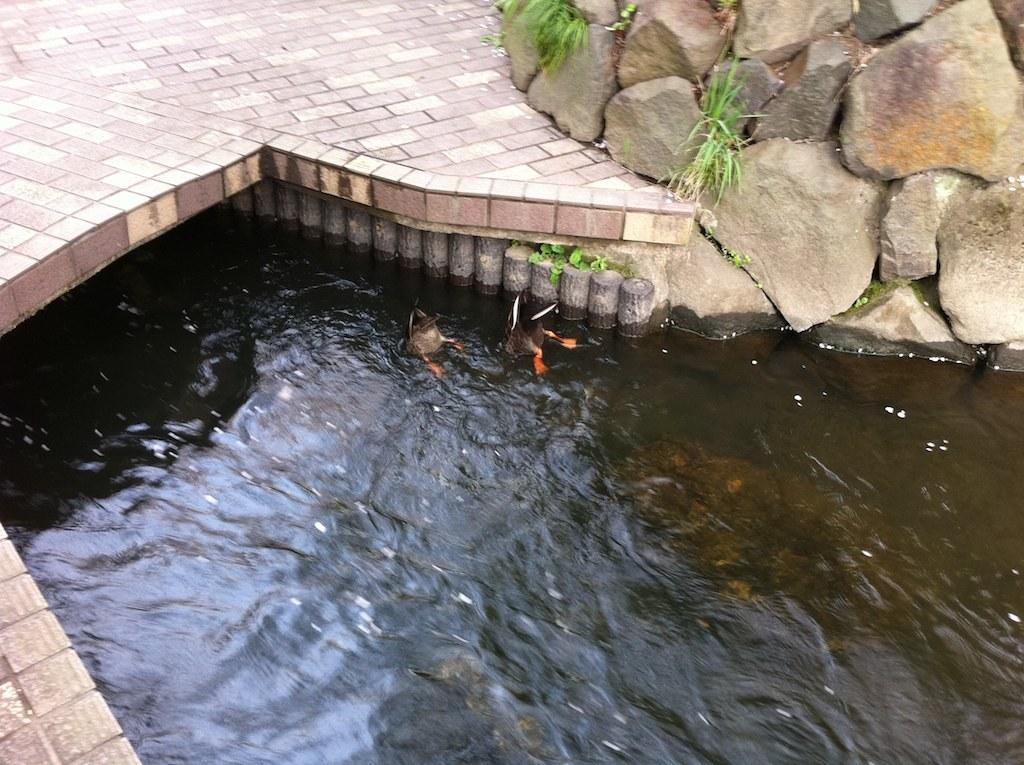What type of animals can be seen in the image? Birds can be seen in the water in the image. What is the primary element in which the birds are situated? The birds are situated in water. What can be seen at the top of the image? There are stones, grass, and a walkway at the top of the image. What type of house does the brother live in, as seen in the image? There is no house or brother present in the image. What type of stem can be seen growing from the grass in the image? There is no stem visible in the image; only grass is mentioned. 